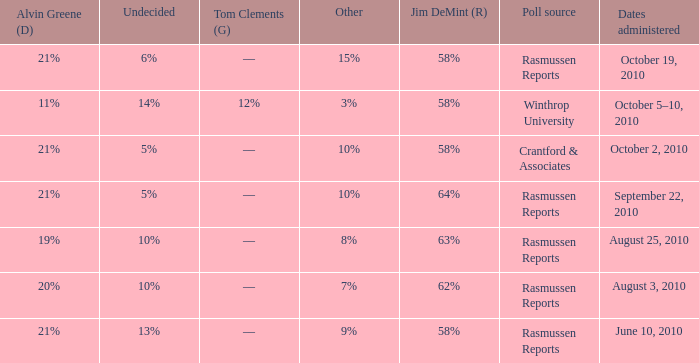What was the vote for Alvin Green when other was 9%? 21%. 